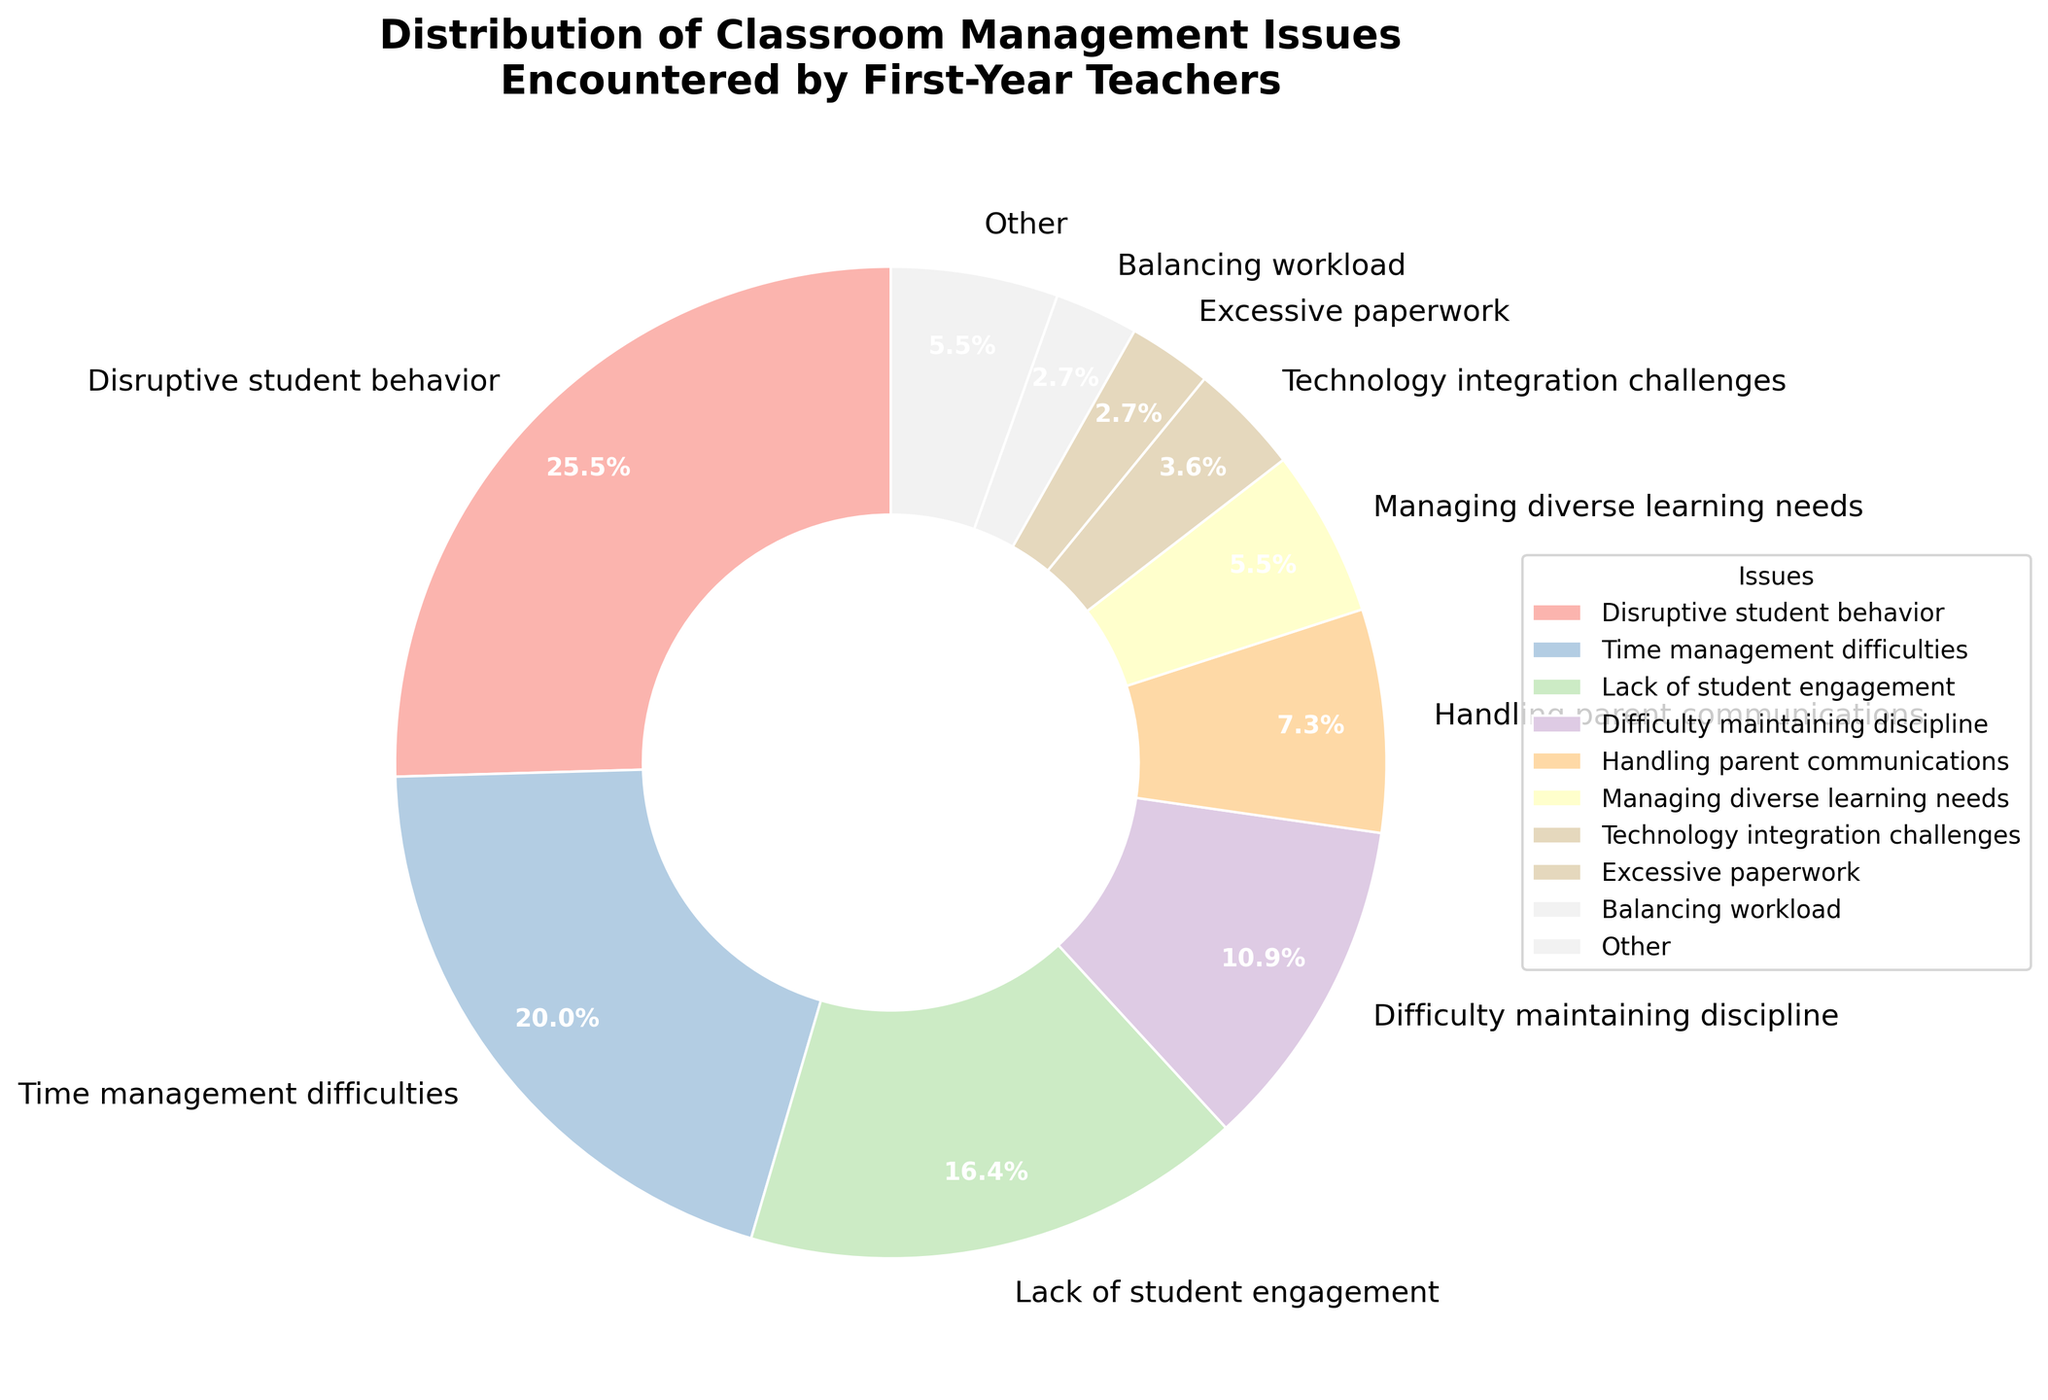What is the most common classroom management issue encountered by first-year teachers? The pie chart shows different classroom management issues and their corresponding percentages. By looking at the wedges, the largest wedge represents "Disruptive student behavior" with 28%.
Answer: Disruptive student behavior Which two issues combined make up 50% of the classroom management problems? The pie chart shows the percentages of various issues. "Disruptive student behavior" is 28% and "Time management difficulties" is 22%. Adding these two provides 28% + 22% = 50%.
Answer: Disruptive student behavior and Time management difficulties Compare "Lack of student engagement" and "Difficulty maintaining discipline" in terms of percentage. Which one is higher and by how much? "Lack of student engagement" is 18% and "Difficulty maintaining discipline" is 12%. The difference is 18% - 12% = 6%. Thus, "Lack of student engagement" is higher by 6%.
Answer: Lack of student engagement by 6% What percentage of issues fall under the "Other" category? The "Other" category in the pie chart combines the percentages of all issues below a certain threshold (3%). These issues summed together form one wedge called "Other." The pie chart indicates "Other" as 16%.
Answer: 16% Which issue follows "Time management difficulties" in terms of prevalence? According to the pie chart, "Time management difficulties" is at 22%, making it the second most common issue. The next largest wedge represents "Lack of student engagement" at 18%.
Answer: Lack of student engagement How many issues individually account for less than 4% of the total? The legend in the pie chart shows the issues along with their percentages. Issues accounting individually for less than 4% are "Technology integration challenges" (4%), "Excessive paperwork" (3%), "Balancing workload" (3%), "Addressing bullying incidents" (2%), "Dealing with attendance issues" (2%), "Managing group activities" (1%), and "Handling conflicts between students" (1%). Counting these, there are 7 issues.
Answer: 7 What is the total percentage accounted for by issues related to managing diverse learning needs and handling parent communications? "Managing diverse learning needs" is 6% and "Handling parent communications" is 8%. Adding these two, we get 6% + 8% = 14%.
Answer: 14% What visual feature indicates the proportion of each classroom management issue in the pie chart? The size of each wedge or slice in the pie chart visually represents the percentage of each classroom management issue. Larger wedges indicate higher percentages and vice versa.
Answer: Wedge size If the percentage for "Managing group activities" were to triple, what would its new percentage be, and how would it compare to "Excessive paperwork"? The current percentage for "Managing group activities" is 1%. Tripling this gives 1% * 3 = 3%. This would then be equal to the percentage for "Excessive paperwork," which is also 3%.
Answer: 3%, equal to Excessive paperwork 